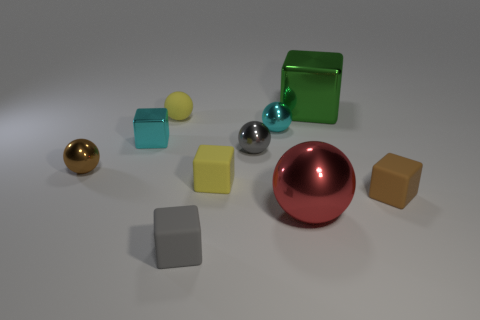Subtract all gray balls. Subtract all cyan cylinders. How many balls are left? 4 Add 1 big green objects. How many big green objects are left? 2 Add 8 yellow objects. How many yellow objects exist? 10 Subtract 0 yellow cylinders. How many objects are left? 10 Subtract all large red metallic balls. Subtract all yellow cubes. How many objects are left? 8 